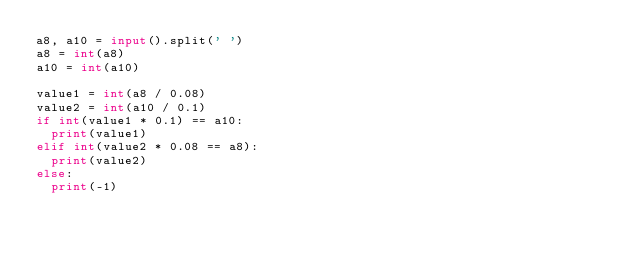<code> <loc_0><loc_0><loc_500><loc_500><_Python_>a8, a10 = input().split(' ')
a8 = int(a8)
a10 = int(a10)
 
value1 = int(a8 / 0.08)
value2 = int(a10 / 0.1)
if int(value1 * 0.1) == a10:
  print(value1)
elif int(value2 * 0.08 == a8):
  print(value2)
else:
  print(-1)</code> 